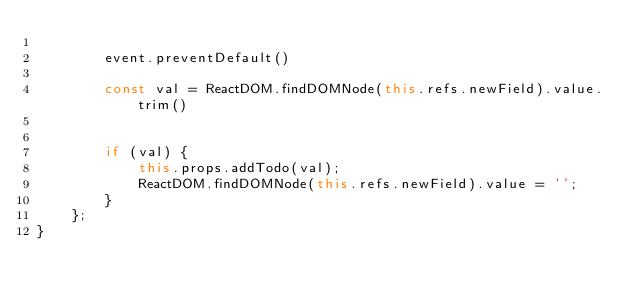<code> <loc_0><loc_0><loc_500><loc_500><_JavaScript_>
		event.preventDefault()

        const val = ReactDOM.findDOMNode(this.refs.newField).value.trim()
        

		if (val) {
			this.props.addTodo(val);
			ReactDOM.findDOMNode(this.refs.newField).value = '';
		}
	};
}</code> 